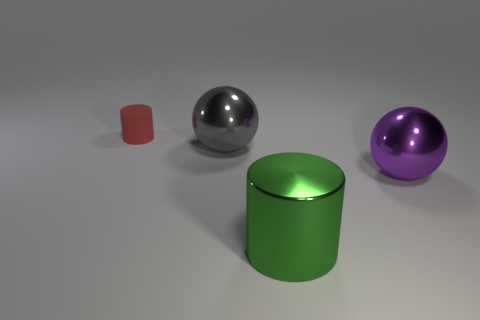Is there any other thing that is made of the same material as the small thing?
Ensure brevity in your answer.  No. Are there any other things of the same color as the big cylinder?
Offer a terse response. No. Is the matte cylinder the same color as the metal cylinder?
Keep it short and to the point. No. How many yellow things are either metallic cylinders or tiny things?
Make the answer very short. 0. Is the number of shiny things that are to the left of the matte object less than the number of big purple metal spheres?
Give a very brief answer. Yes. There is a large shiny ball right of the big gray sphere; how many balls are on the left side of it?
Give a very brief answer. 1. How many other things are there of the same size as the purple metallic ball?
Your answer should be very brief. 2. What number of objects are either gray metallic balls or big things in front of the large gray metal object?
Ensure brevity in your answer.  3. Are there fewer big green metallic objects than small cyan objects?
Provide a succinct answer. No. The cylinder that is behind the metal object that is on the right side of the big green thing is what color?
Your answer should be very brief. Red. 